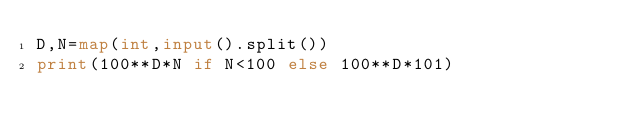<code> <loc_0><loc_0><loc_500><loc_500><_Python_>D,N=map(int,input().split())
print(100**D*N if N<100 else 100**D*101)</code> 